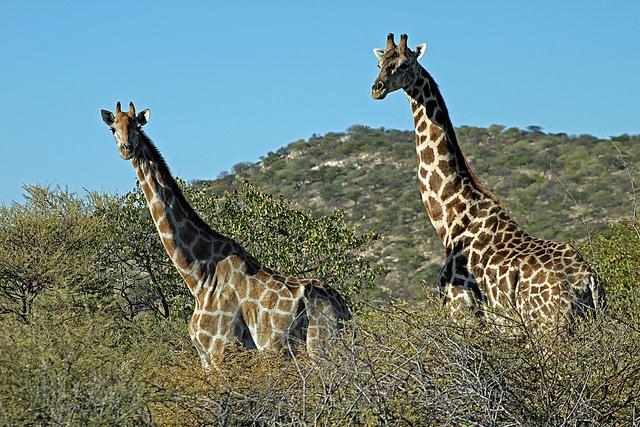Are there clouds in the sky?
Answer briefly. No. How many giraffes are in this scene?
Keep it brief. 2. How many giraffes are looking at the camera?
Quick response, please. 1. 